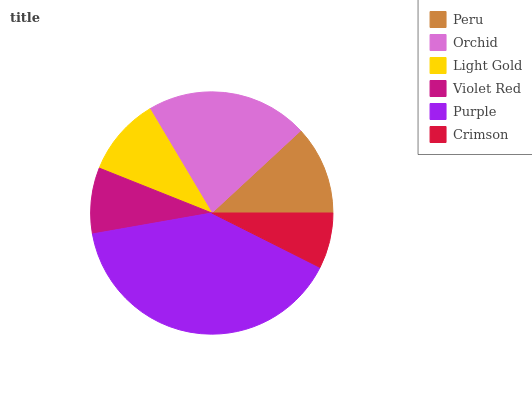Is Crimson the minimum?
Answer yes or no. Yes. Is Purple the maximum?
Answer yes or no. Yes. Is Orchid the minimum?
Answer yes or no. No. Is Orchid the maximum?
Answer yes or no. No. Is Orchid greater than Peru?
Answer yes or no. Yes. Is Peru less than Orchid?
Answer yes or no. Yes. Is Peru greater than Orchid?
Answer yes or no. No. Is Orchid less than Peru?
Answer yes or no. No. Is Peru the high median?
Answer yes or no. Yes. Is Light Gold the low median?
Answer yes or no. Yes. Is Crimson the high median?
Answer yes or no. No. Is Violet Red the low median?
Answer yes or no. No. 